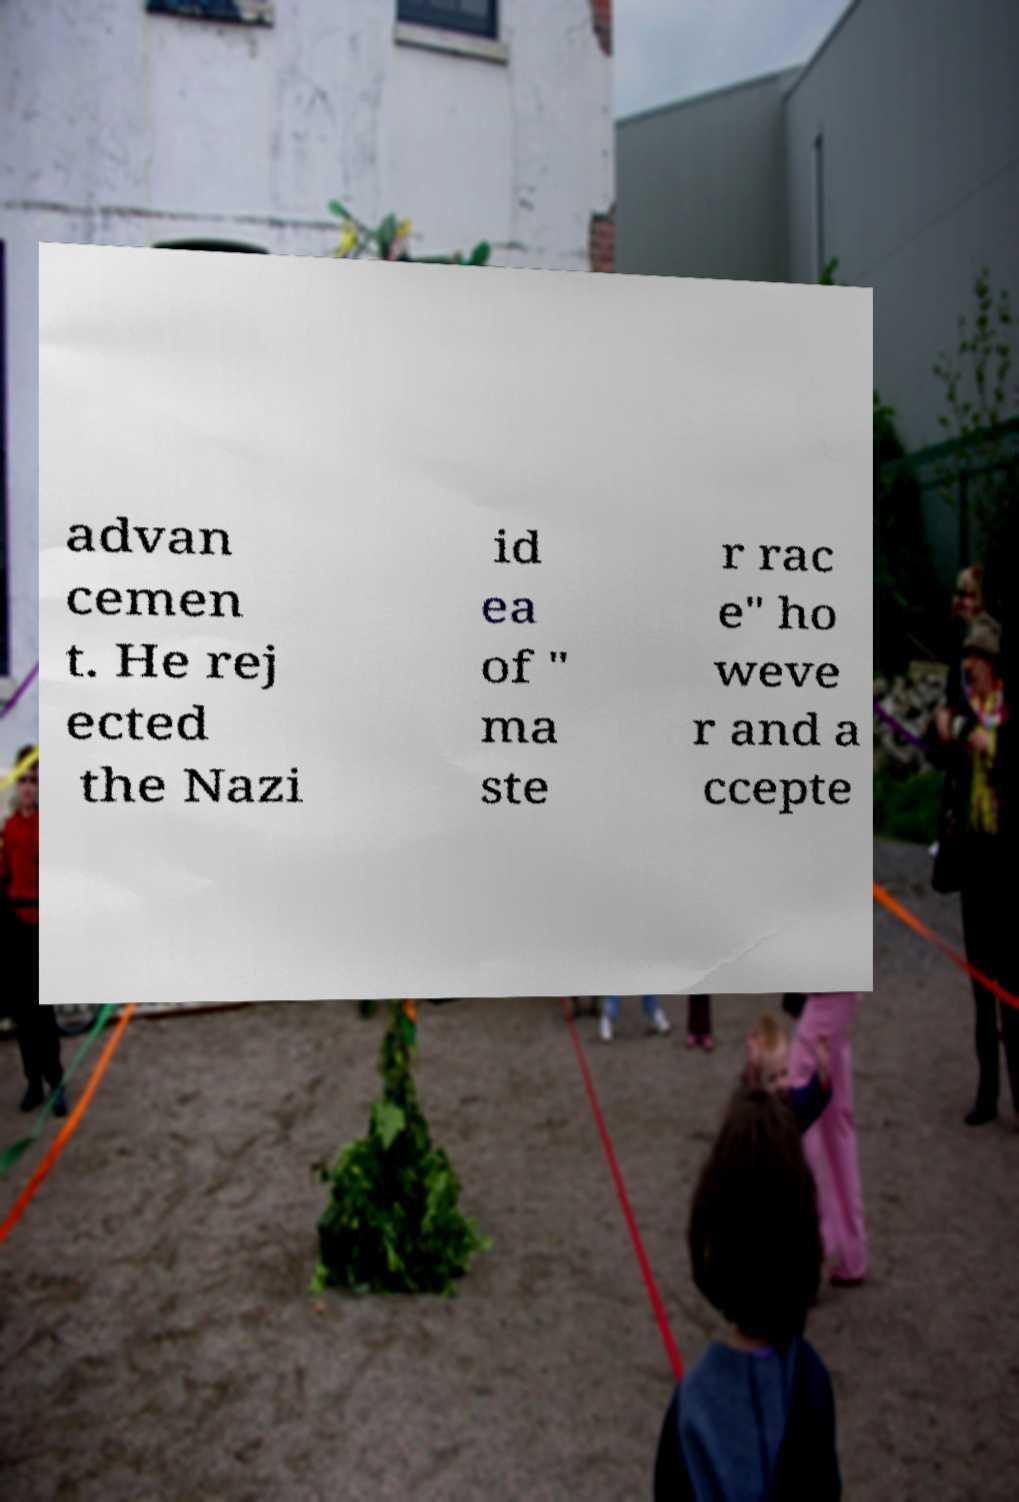Could you assist in decoding the text presented in this image and type it out clearly? advan cemen t. He rej ected the Nazi id ea of " ma ste r rac e" ho weve r and a ccepte 